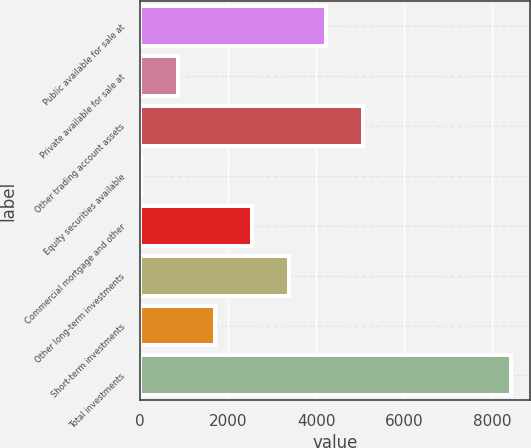<chart> <loc_0><loc_0><loc_500><loc_500><bar_chart><fcel>Public available for sale at<fcel>Private available for sale at<fcel>Other trading account assets<fcel>Equity securities available<fcel>Commercial mortgage and other<fcel>Other long-term investments<fcel>Short-term investments<fcel>Total investments<nl><fcel>4227.5<fcel>855.9<fcel>5070.4<fcel>13<fcel>2541.7<fcel>3384.6<fcel>1698.8<fcel>8442<nl></chart> 